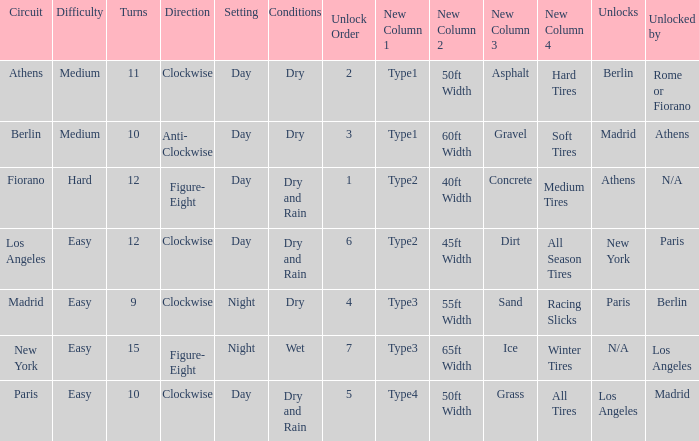How many instances is the unlocked n/a? 1.0. 